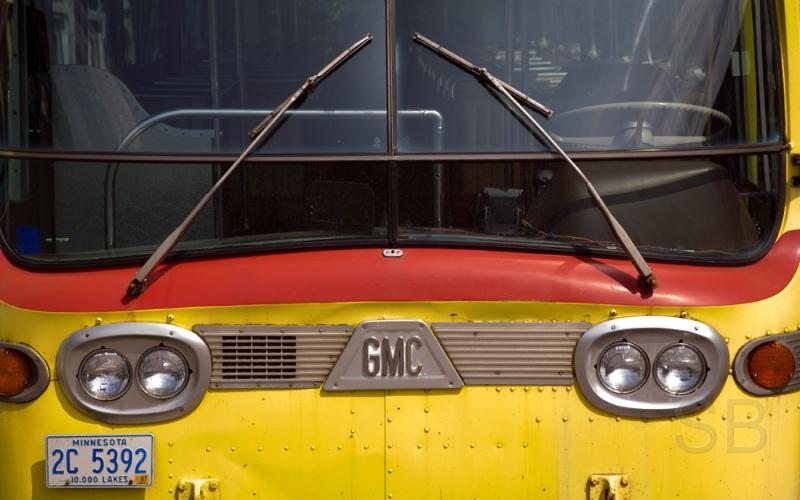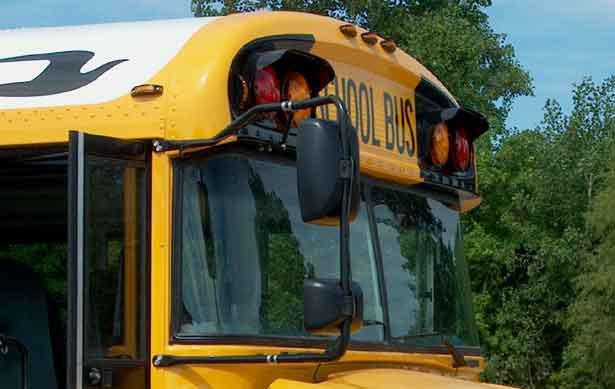The first image is the image on the left, the second image is the image on the right. For the images displayed, is the sentence "In at least one image there is a single view of a flat front end bus with its windshield wiper up." factually correct? Answer yes or no. Yes. The first image is the image on the left, the second image is the image on the right. Considering the images on both sides, is "At least one of the images shows a bus from the right side and its stop sign is visible." valid? Answer yes or no. No. 